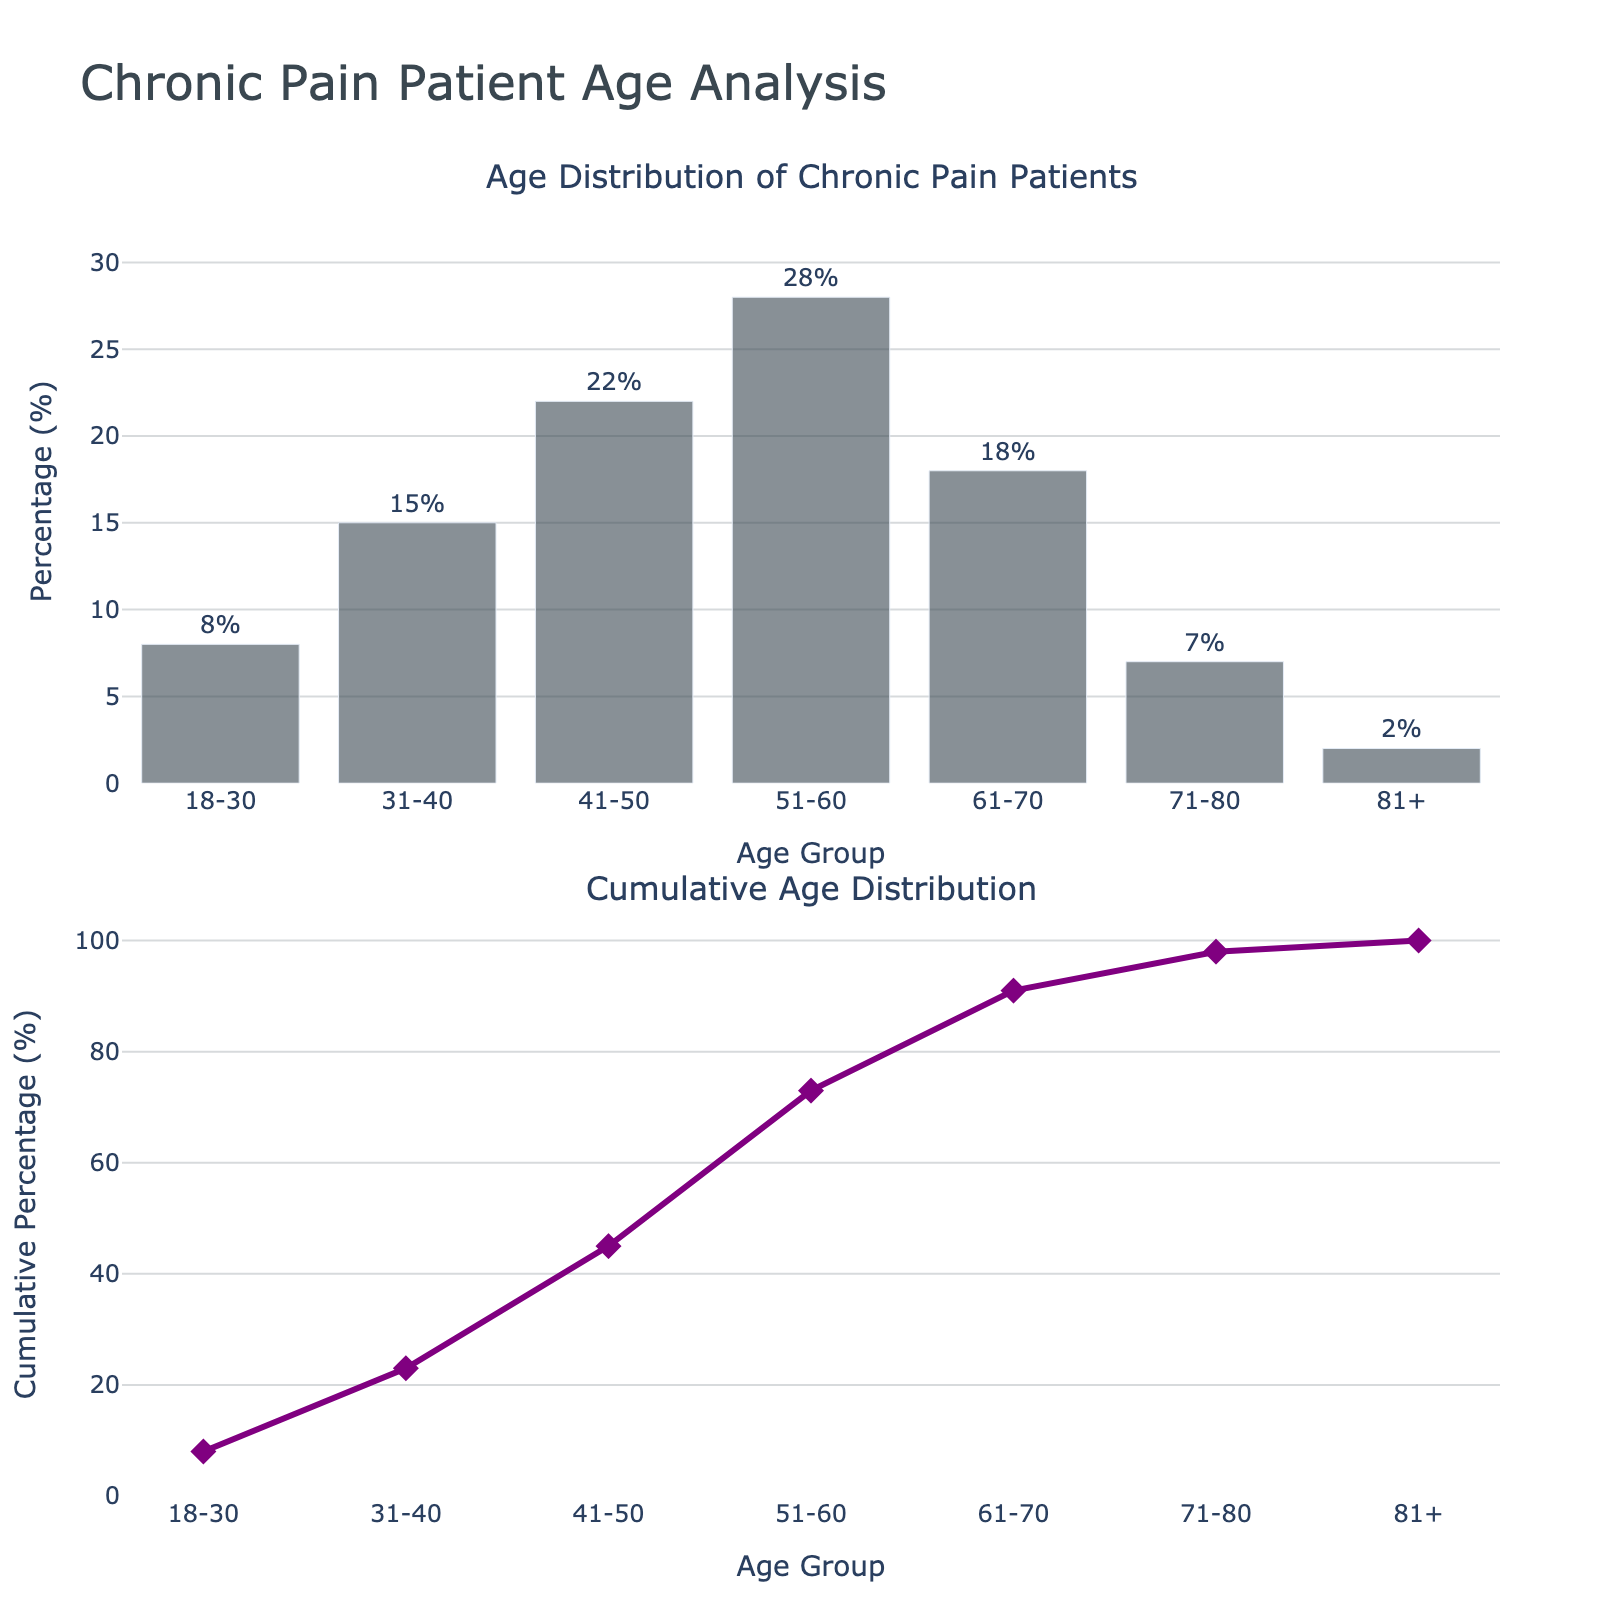What's the title of the first subplot? The title of the first subplot is located at the top of the bar plot, which is labeled as "Age Distribution of Chronic Pain Patients."
Answer: Age Distribution of Chronic Pain Patients What's the percentage of patients in the age group 51-60? Look at the bar corresponding to the age group "51-60" in the first subplot and read the percentage value. It is labeled at the top of the bar.
Answer: 28% Which age group has the highest percentage of patients seeking chronic pain treatment? Identify the tallest bar in the first subplot of the figure and read the age group label below it. The "51-60" age group has the tallest bar.
Answer: 51-60 What is the cumulative percentage for the age group 41-50? Locate the age group "41-50" in the second subplot, follow the line plot vertically to its value, and read the cumulative percentage. The cumulative percentage for 41-50 is marked at the top of the line.
Answer: 45% What is the cumulative percentage for ages 31-40 through 51-60? Sum the individual percentages for the ages 31-40, 41-50, and 51-60 from the bar plot and add them cumulatively: (15 + 22 + 28). These values are cumulative, so the result represents the cumulative percentage through 51-60.
Answer: 65% How many age groups have a percentage of patients greater than 15%? Look at the y-values in the first subplot, count the bars with a percentage above 15%. The age groups are 41-50, 51-60, and 61-70.
Answer: 3 Compare the percentages of patients in age groups 31-40 and 71-80. Which one is higher? Examine the percentages for age groups "31-40" and "71-80" in the first subplot. "31-40" shows 15% while "71-80" shows 7%.
Answer: 31-40 What's the overall trend in the cumulative percentage as age groups increase? Observe the line trend in the second subplot. The cumulative percentage increases as the age groups go from "18-30" to "81+," which means it's an increasing trend.
Answer: Increasing What is the cumulative percentage before reaching the age group 61-70? Add the percentages of all preceding age groups up to "51-60" and stop before "61-70." The cumulative sum is 73% up to "51-60."
Answer: 65% What is the difference in percentage between the age groups 51-60 and 71-80? Subtract the percentage value of "71-80" from "51-60" given in the first subplot. That is 28% - 7%.
Answer: 21% 